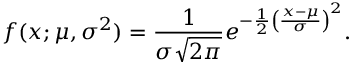Convert formula to latex. <formula><loc_0><loc_0><loc_500><loc_500>f ( x ; \mu , \sigma ^ { 2 } ) = { \frac { 1 } { \sigma { \sqrt { 2 \pi } } } } e ^ { - { \frac { 1 } { 2 } } \left ( { \frac { x - \mu } { \sigma } } \right ) ^ { 2 } } .</formula> 